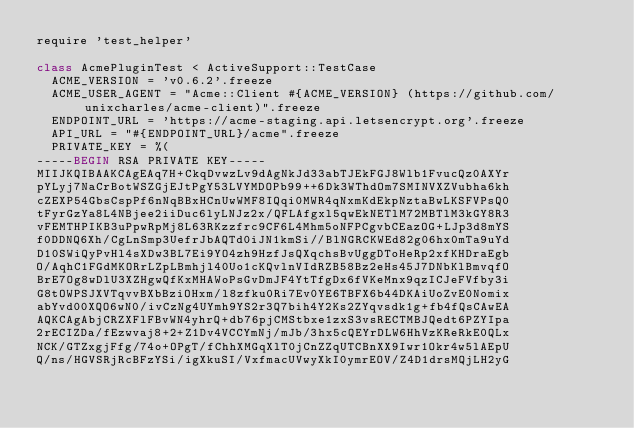Convert code to text. <code><loc_0><loc_0><loc_500><loc_500><_Ruby_>require 'test_helper'

class AcmePluginTest < ActiveSupport::TestCase
  ACME_VERSION = 'v0.6.2'.freeze
  ACME_USER_AGENT = "Acme::Client #{ACME_VERSION} (https://github.com/unixcharles/acme-client)".freeze
  ENDPOINT_URL = 'https://acme-staging.api.letsencrypt.org'.freeze
  API_URL = "#{ENDPOINT_URL}/acme".freeze
  PRIVATE_KEY = %(
-----BEGIN RSA PRIVATE KEY-----
MIIJKQIBAAKCAgEAq7H+CkqDvwzLv9dAgNkJd33abTJEkFGJ8Wlb1FvucQz0AXYr
pYLyj7NaCrBotWSZGjEJtPgY53LVYMDOPb99++6Dk3WThdOm7SMINVXZVubha6kh
cZEXP54GbsCspPf6nNqBBxHCnUwWMF8IQqi0MWR4qNxmKdEkpNztaBwLKSFVPsQ0
tFyrGzYa8L4NBjee2iiDuc6lyLNJz2x/QFLAfgxl5qwEkNETlM72MBTlM3kGY8R3
vFEMTHPIKB3uPpwRpMj8L63RKzzfrc9CF6L4Mhm5oNFPCgvbCEazOG+LJp3d8mYS
f0DDNQ6Xh/CgLnSmp3UefrJbAQTd0iJN1kmSi//BlNGRCKWEd82g06hx0mTa9uYd
D10SWiQyPvHl4sXDw3BL7Ei9YO4zh9HzfJsQXqchsBvUggDToHeRp2xfKHDraEgb
O/AqhC1FGdMKORrLZpLBmhjl40Uo1cKQvlnVIdRZB58Bz2eHs45J7DNbKlBmvqfO
BrE7Og8wDlU3XZHgwQfKxMHAWoPsGvDmJF4YtTfgDx6fVKeMnx9qzICJeFVfby3i
G8tOWPSJXVTqvvBXbBziOHxm/l8zfku0Ri7Ev0YE6TBFX6b44DKAiUoZvE0Nomix
abYvd00XQO6wN0/ivCzNg4UYmh9YS2r3Q7bih4Y2Ks2ZYqvsdk1g+fb4fQsCAwEA
AQKCAgAbjCRZXFlFBvWN4yhrQ+db76pjCMStbxe1zxS3vsRECTMBJQedt6PZYIpa
2rECIZDa/fEzwvaj8+2+Z1Dv4VCCYmNj/mJb/3hx5cQEYrDLW6HhVzKReRkE0QLx
NCK/GTZxgjFfg/74o+OPgT/fChhXMGqXlT0jCnZZqUTCBnXX9Iwr1Okr4w5lAEpU
Q/ns/HGVSRjRcBFzYSi/igXkuSI/VxfmacUVwyXkI0ymrEOV/Z4D1drsMQjLH2yG</code> 